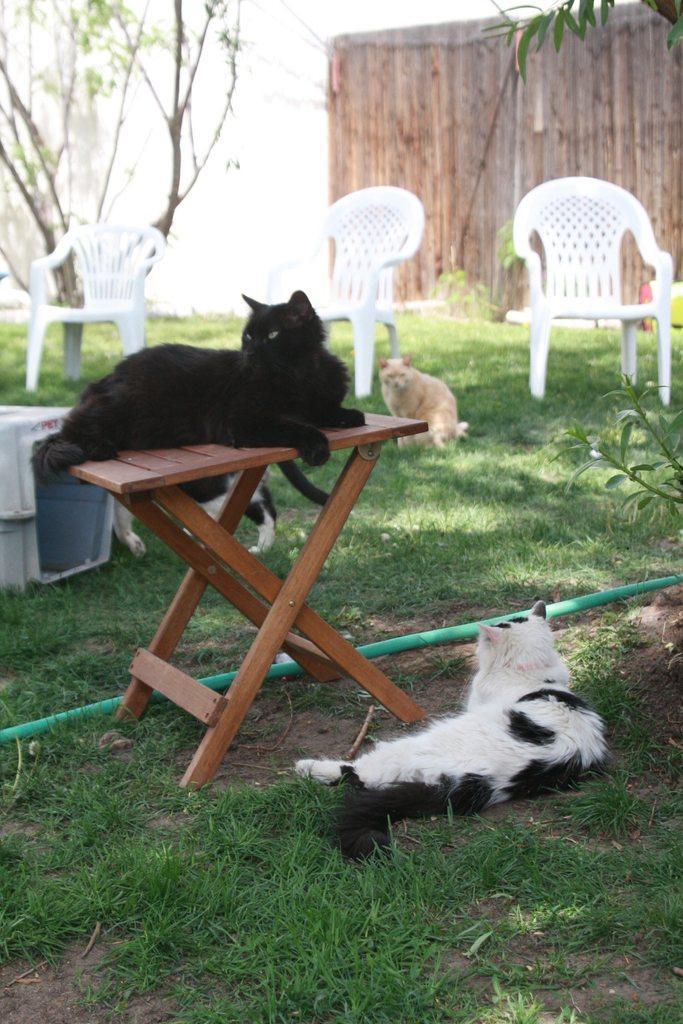Please provide a concise description of this image. On the background we can see tree, chairs on a grass. we can see a cat on the grass here sitting. This is a cat and on the table we can see a black cat. Here we can see a pipe in green colour. 